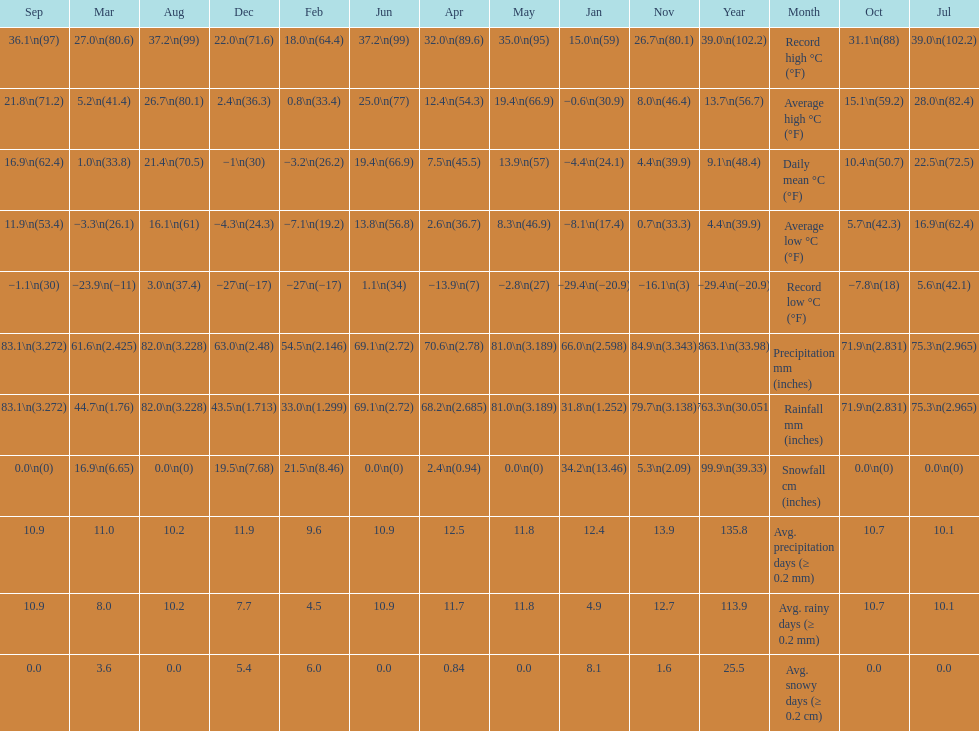How many months had a record high of over 15.0 degrees? 11. 